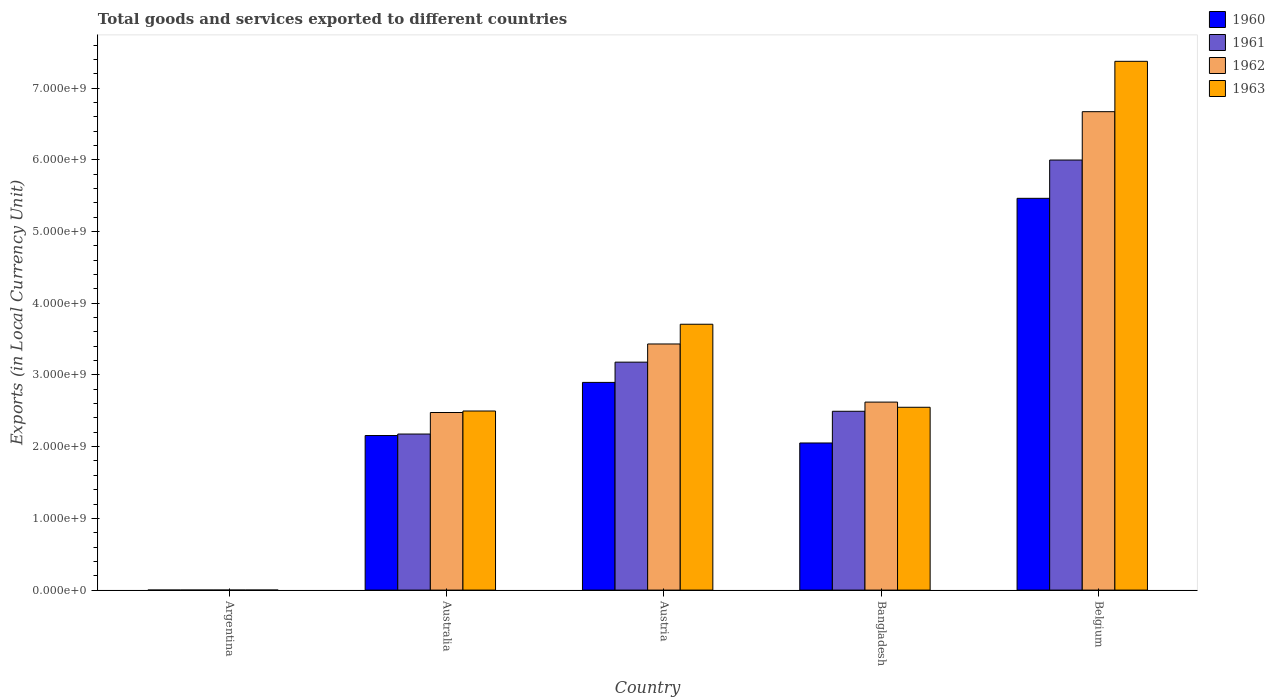How many groups of bars are there?
Provide a short and direct response. 5. Are the number of bars per tick equal to the number of legend labels?
Offer a very short reply. Yes. Are the number of bars on each tick of the X-axis equal?
Your answer should be compact. Yes. How many bars are there on the 2nd tick from the left?
Give a very brief answer. 4. What is the label of the 1st group of bars from the left?
Give a very brief answer. Argentina. What is the Amount of goods and services exports in 1961 in Australia?
Provide a short and direct response. 2.18e+09. Across all countries, what is the maximum Amount of goods and services exports in 1961?
Keep it short and to the point. 6.00e+09. Across all countries, what is the minimum Amount of goods and services exports in 1961?
Your answer should be compact. 0.01. What is the total Amount of goods and services exports in 1962 in the graph?
Ensure brevity in your answer.  1.52e+1. What is the difference between the Amount of goods and services exports in 1961 in Australia and that in Belgium?
Provide a succinct answer. -3.82e+09. What is the difference between the Amount of goods and services exports in 1962 in Argentina and the Amount of goods and services exports in 1961 in Bangladesh?
Keep it short and to the point. -2.49e+09. What is the average Amount of goods and services exports in 1963 per country?
Provide a succinct answer. 3.23e+09. What is the difference between the Amount of goods and services exports of/in 1960 and Amount of goods and services exports of/in 1963 in Argentina?
Provide a succinct answer. -0.01. What is the ratio of the Amount of goods and services exports in 1963 in Australia to that in Bangladesh?
Provide a succinct answer. 0.98. Is the Amount of goods and services exports in 1963 in Argentina less than that in Austria?
Offer a very short reply. Yes. What is the difference between the highest and the second highest Amount of goods and services exports in 1963?
Your answer should be very brief. 3.67e+09. What is the difference between the highest and the lowest Amount of goods and services exports in 1963?
Keep it short and to the point. 7.37e+09. Is the sum of the Amount of goods and services exports in 1963 in Australia and Austria greater than the maximum Amount of goods and services exports in 1960 across all countries?
Keep it short and to the point. Yes. What does the 1st bar from the left in Argentina represents?
Provide a succinct answer. 1960. What does the 3rd bar from the right in Australia represents?
Offer a terse response. 1961. Is it the case that in every country, the sum of the Amount of goods and services exports in 1963 and Amount of goods and services exports in 1961 is greater than the Amount of goods and services exports in 1962?
Keep it short and to the point. Yes. How many bars are there?
Provide a succinct answer. 20. Are all the bars in the graph horizontal?
Give a very brief answer. No. What is the difference between two consecutive major ticks on the Y-axis?
Keep it short and to the point. 1.00e+09. Are the values on the major ticks of Y-axis written in scientific E-notation?
Give a very brief answer. Yes. Does the graph contain any zero values?
Provide a succinct answer. No. How many legend labels are there?
Provide a succinct answer. 4. What is the title of the graph?
Keep it short and to the point. Total goods and services exported to different countries. Does "1970" appear as one of the legend labels in the graph?
Provide a short and direct response. No. What is the label or title of the X-axis?
Make the answer very short. Country. What is the label or title of the Y-axis?
Provide a short and direct response. Exports (in Local Currency Unit). What is the Exports (in Local Currency Unit) in 1960 in Argentina?
Offer a terse response. 0.01. What is the Exports (in Local Currency Unit) of 1961 in Argentina?
Your answer should be compact. 0.01. What is the Exports (in Local Currency Unit) in 1962 in Argentina?
Give a very brief answer. 0.01. What is the Exports (in Local Currency Unit) in 1963 in Argentina?
Your answer should be very brief. 0.02. What is the Exports (in Local Currency Unit) in 1960 in Australia?
Offer a terse response. 2.16e+09. What is the Exports (in Local Currency Unit) in 1961 in Australia?
Keep it short and to the point. 2.18e+09. What is the Exports (in Local Currency Unit) of 1962 in Australia?
Give a very brief answer. 2.48e+09. What is the Exports (in Local Currency Unit) of 1963 in Australia?
Provide a short and direct response. 2.50e+09. What is the Exports (in Local Currency Unit) of 1960 in Austria?
Offer a terse response. 2.90e+09. What is the Exports (in Local Currency Unit) in 1961 in Austria?
Your answer should be very brief. 3.18e+09. What is the Exports (in Local Currency Unit) in 1962 in Austria?
Provide a short and direct response. 3.43e+09. What is the Exports (in Local Currency Unit) of 1963 in Austria?
Offer a very short reply. 3.71e+09. What is the Exports (in Local Currency Unit) of 1960 in Bangladesh?
Keep it short and to the point. 2.05e+09. What is the Exports (in Local Currency Unit) in 1961 in Bangladesh?
Provide a succinct answer. 2.49e+09. What is the Exports (in Local Currency Unit) of 1962 in Bangladesh?
Keep it short and to the point. 2.62e+09. What is the Exports (in Local Currency Unit) of 1963 in Bangladesh?
Your answer should be very brief. 2.55e+09. What is the Exports (in Local Currency Unit) of 1960 in Belgium?
Give a very brief answer. 5.46e+09. What is the Exports (in Local Currency Unit) of 1961 in Belgium?
Give a very brief answer. 6.00e+09. What is the Exports (in Local Currency Unit) of 1962 in Belgium?
Provide a succinct answer. 6.67e+09. What is the Exports (in Local Currency Unit) of 1963 in Belgium?
Your answer should be compact. 7.37e+09. Across all countries, what is the maximum Exports (in Local Currency Unit) of 1960?
Offer a terse response. 5.46e+09. Across all countries, what is the maximum Exports (in Local Currency Unit) in 1961?
Your answer should be compact. 6.00e+09. Across all countries, what is the maximum Exports (in Local Currency Unit) of 1962?
Offer a terse response. 6.67e+09. Across all countries, what is the maximum Exports (in Local Currency Unit) in 1963?
Your response must be concise. 7.37e+09. Across all countries, what is the minimum Exports (in Local Currency Unit) of 1960?
Your answer should be very brief. 0.01. Across all countries, what is the minimum Exports (in Local Currency Unit) in 1961?
Ensure brevity in your answer.  0.01. Across all countries, what is the minimum Exports (in Local Currency Unit) of 1962?
Keep it short and to the point. 0.01. Across all countries, what is the minimum Exports (in Local Currency Unit) of 1963?
Provide a succinct answer. 0.02. What is the total Exports (in Local Currency Unit) of 1960 in the graph?
Your response must be concise. 1.26e+1. What is the total Exports (in Local Currency Unit) in 1961 in the graph?
Offer a terse response. 1.38e+1. What is the total Exports (in Local Currency Unit) in 1962 in the graph?
Give a very brief answer. 1.52e+1. What is the total Exports (in Local Currency Unit) in 1963 in the graph?
Keep it short and to the point. 1.61e+1. What is the difference between the Exports (in Local Currency Unit) in 1960 in Argentina and that in Australia?
Your response must be concise. -2.15e+09. What is the difference between the Exports (in Local Currency Unit) in 1961 in Argentina and that in Australia?
Give a very brief answer. -2.18e+09. What is the difference between the Exports (in Local Currency Unit) in 1962 in Argentina and that in Australia?
Make the answer very short. -2.48e+09. What is the difference between the Exports (in Local Currency Unit) of 1963 in Argentina and that in Australia?
Give a very brief answer. -2.50e+09. What is the difference between the Exports (in Local Currency Unit) in 1960 in Argentina and that in Austria?
Your answer should be very brief. -2.90e+09. What is the difference between the Exports (in Local Currency Unit) in 1961 in Argentina and that in Austria?
Provide a short and direct response. -3.18e+09. What is the difference between the Exports (in Local Currency Unit) in 1962 in Argentina and that in Austria?
Your answer should be very brief. -3.43e+09. What is the difference between the Exports (in Local Currency Unit) in 1963 in Argentina and that in Austria?
Your response must be concise. -3.71e+09. What is the difference between the Exports (in Local Currency Unit) of 1960 in Argentina and that in Bangladesh?
Provide a short and direct response. -2.05e+09. What is the difference between the Exports (in Local Currency Unit) of 1961 in Argentina and that in Bangladesh?
Offer a terse response. -2.49e+09. What is the difference between the Exports (in Local Currency Unit) in 1962 in Argentina and that in Bangladesh?
Provide a succinct answer. -2.62e+09. What is the difference between the Exports (in Local Currency Unit) of 1963 in Argentina and that in Bangladesh?
Keep it short and to the point. -2.55e+09. What is the difference between the Exports (in Local Currency Unit) in 1960 in Argentina and that in Belgium?
Provide a succinct answer. -5.46e+09. What is the difference between the Exports (in Local Currency Unit) of 1961 in Argentina and that in Belgium?
Provide a short and direct response. -6.00e+09. What is the difference between the Exports (in Local Currency Unit) of 1962 in Argentina and that in Belgium?
Provide a succinct answer. -6.67e+09. What is the difference between the Exports (in Local Currency Unit) in 1963 in Argentina and that in Belgium?
Offer a very short reply. -7.37e+09. What is the difference between the Exports (in Local Currency Unit) in 1960 in Australia and that in Austria?
Your response must be concise. -7.41e+08. What is the difference between the Exports (in Local Currency Unit) in 1961 in Australia and that in Austria?
Keep it short and to the point. -1.00e+09. What is the difference between the Exports (in Local Currency Unit) in 1962 in Australia and that in Austria?
Your response must be concise. -9.56e+08. What is the difference between the Exports (in Local Currency Unit) in 1963 in Australia and that in Austria?
Your response must be concise. -1.21e+09. What is the difference between the Exports (in Local Currency Unit) of 1960 in Australia and that in Bangladesh?
Offer a terse response. 1.04e+08. What is the difference between the Exports (in Local Currency Unit) of 1961 in Australia and that in Bangladesh?
Keep it short and to the point. -3.17e+08. What is the difference between the Exports (in Local Currency Unit) in 1962 in Australia and that in Bangladesh?
Offer a very short reply. -1.45e+08. What is the difference between the Exports (in Local Currency Unit) in 1963 in Australia and that in Bangladesh?
Your answer should be very brief. -5.21e+07. What is the difference between the Exports (in Local Currency Unit) of 1960 in Australia and that in Belgium?
Keep it short and to the point. -3.31e+09. What is the difference between the Exports (in Local Currency Unit) in 1961 in Australia and that in Belgium?
Your response must be concise. -3.82e+09. What is the difference between the Exports (in Local Currency Unit) of 1962 in Australia and that in Belgium?
Give a very brief answer. -4.19e+09. What is the difference between the Exports (in Local Currency Unit) of 1963 in Australia and that in Belgium?
Provide a succinct answer. -4.88e+09. What is the difference between the Exports (in Local Currency Unit) in 1960 in Austria and that in Bangladesh?
Your response must be concise. 8.45e+08. What is the difference between the Exports (in Local Currency Unit) in 1961 in Austria and that in Bangladesh?
Keep it short and to the point. 6.85e+08. What is the difference between the Exports (in Local Currency Unit) of 1962 in Austria and that in Bangladesh?
Keep it short and to the point. 8.10e+08. What is the difference between the Exports (in Local Currency Unit) of 1963 in Austria and that in Bangladesh?
Provide a short and direct response. 1.16e+09. What is the difference between the Exports (in Local Currency Unit) in 1960 in Austria and that in Belgium?
Your answer should be very brief. -2.57e+09. What is the difference between the Exports (in Local Currency Unit) of 1961 in Austria and that in Belgium?
Provide a short and direct response. -2.82e+09. What is the difference between the Exports (in Local Currency Unit) in 1962 in Austria and that in Belgium?
Give a very brief answer. -3.24e+09. What is the difference between the Exports (in Local Currency Unit) of 1963 in Austria and that in Belgium?
Offer a very short reply. -3.67e+09. What is the difference between the Exports (in Local Currency Unit) of 1960 in Bangladesh and that in Belgium?
Your answer should be very brief. -3.41e+09. What is the difference between the Exports (in Local Currency Unit) in 1961 in Bangladesh and that in Belgium?
Provide a short and direct response. -3.50e+09. What is the difference between the Exports (in Local Currency Unit) of 1962 in Bangladesh and that in Belgium?
Keep it short and to the point. -4.05e+09. What is the difference between the Exports (in Local Currency Unit) in 1963 in Bangladesh and that in Belgium?
Provide a short and direct response. -4.82e+09. What is the difference between the Exports (in Local Currency Unit) in 1960 in Argentina and the Exports (in Local Currency Unit) in 1961 in Australia?
Provide a short and direct response. -2.18e+09. What is the difference between the Exports (in Local Currency Unit) in 1960 in Argentina and the Exports (in Local Currency Unit) in 1962 in Australia?
Give a very brief answer. -2.48e+09. What is the difference between the Exports (in Local Currency Unit) in 1960 in Argentina and the Exports (in Local Currency Unit) in 1963 in Australia?
Offer a very short reply. -2.50e+09. What is the difference between the Exports (in Local Currency Unit) of 1961 in Argentina and the Exports (in Local Currency Unit) of 1962 in Australia?
Your answer should be compact. -2.48e+09. What is the difference between the Exports (in Local Currency Unit) in 1961 in Argentina and the Exports (in Local Currency Unit) in 1963 in Australia?
Offer a very short reply. -2.50e+09. What is the difference between the Exports (in Local Currency Unit) of 1962 in Argentina and the Exports (in Local Currency Unit) of 1963 in Australia?
Make the answer very short. -2.50e+09. What is the difference between the Exports (in Local Currency Unit) in 1960 in Argentina and the Exports (in Local Currency Unit) in 1961 in Austria?
Ensure brevity in your answer.  -3.18e+09. What is the difference between the Exports (in Local Currency Unit) of 1960 in Argentina and the Exports (in Local Currency Unit) of 1962 in Austria?
Give a very brief answer. -3.43e+09. What is the difference between the Exports (in Local Currency Unit) in 1960 in Argentina and the Exports (in Local Currency Unit) in 1963 in Austria?
Give a very brief answer. -3.71e+09. What is the difference between the Exports (in Local Currency Unit) of 1961 in Argentina and the Exports (in Local Currency Unit) of 1962 in Austria?
Make the answer very short. -3.43e+09. What is the difference between the Exports (in Local Currency Unit) of 1961 in Argentina and the Exports (in Local Currency Unit) of 1963 in Austria?
Your answer should be compact. -3.71e+09. What is the difference between the Exports (in Local Currency Unit) in 1962 in Argentina and the Exports (in Local Currency Unit) in 1963 in Austria?
Your answer should be compact. -3.71e+09. What is the difference between the Exports (in Local Currency Unit) of 1960 in Argentina and the Exports (in Local Currency Unit) of 1961 in Bangladesh?
Make the answer very short. -2.49e+09. What is the difference between the Exports (in Local Currency Unit) of 1960 in Argentina and the Exports (in Local Currency Unit) of 1962 in Bangladesh?
Your answer should be very brief. -2.62e+09. What is the difference between the Exports (in Local Currency Unit) in 1960 in Argentina and the Exports (in Local Currency Unit) in 1963 in Bangladesh?
Your response must be concise. -2.55e+09. What is the difference between the Exports (in Local Currency Unit) of 1961 in Argentina and the Exports (in Local Currency Unit) of 1962 in Bangladesh?
Keep it short and to the point. -2.62e+09. What is the difference between the Exports (in Local Currency Unit) in 1961 in Argentina and the Exports (in Local Currency Unit) in 1963 in Bangladesh?
Provide a short and direct response. -2.55e+09. What is the difference between the Exports (in Local Currency Unit) in 1962 in Argentina and the Exports (in Local Currency Unit) in 1963 in Bangladesh?
Provide a short and direct response. -2.55e+09. What is the difference between the Exports (in Local Currency Unit) in 1960 in Argentina and the Exports (in Local Currency Unit) in 1961 in Belgium?
Offer a very short reply. -6.00e+09. What is the difference between the Exports (in Local Currency Unit) in 1960 in Argentina and the Exports (in Local Currency Unit) in 1962 in Belgium?
Your response must be concise. -6.67e+09. What is the difference between the Exports (in Local Currency Unit) of 1960 in Argentina and the Exports (in Local Currency Unit) of 1963 in Belgium?
Make the answer very short. -7.37e+09. What is the difference between the Exports (in Local Currency Unit) of 1961 in Argentina and the Exports (in Local Currency Unit) of 1962 in Belgium?
Provide a succinct answer. -6.67e+09. What is the difference between the Exports (in Local Currency Unit) in 1961 in Argentina and the Exports (in Local Currency Unit) in 1963 in Belgium?
Make the answer very short. -7.37e+09. What is the difference between the Exports (in Local Currency Unit) in 1962 in Argentina and the Exports (in Local Currency Unit) in 1963 in Belgium?
Your answer should be very brief. -7.37e+09. What is the difference between the Exports (in Local Currency Unit) in 1960 in Australia and the Exports (in Local Currency Unit) in 1961 in Austria?
Provide a succinct answer. -1.02e+09. What is the difference between the Exports (in Local Currency Unit) of 1960 in Australia and the Exports (in Local Currency Unit) of 1962 in Austria?
Your answer should be compact. -1.28e+09. What is the difference between the Exports (in Local Currency Unit) of 1960 in Australia and the Exports (in Local Currency Unit) of 1963 in Austria?
Offer a terse response. -1.55e+09. What is the difference between the Exports (in Local Currency Unit) of 1961 in Australia and the Exports (in Local Currency Unit) of 1962 in Austria?
Provide a short and direct response. -1.26e+09. What is the difference between the Exports (in Local Currency Unit) of 1961 in Australia and the Exports (in Local Currency Unit) of 1963 in Austria?
Your response must be concise. -1.53e+09. What is the difference between the Exports (in Local Currency Unit) of 1962 in Australia and the Exports (in Local Currency Unit) of 1963 in Austria?
Your answer should be compact. -1.23e+09. What is the difference between the Exports (in Local Currency Unit) in 1960 in Australia and the Exports (in Local Currency Unit) in 1961 in Bangladesh?
Give a very brief answer. -3.38e+08. What is the difference between the Exports (in Local Currency Unit) in 1960 in Australia and the Exports (in Local Currency Unit) in 1962 in Bangladesh?
Provide a succinct answer. -4.66e+08. What is the difference between the Exports (in Local Currency Unit) of 1960 in Australia and the Exports (in Local Currency Unit) of 1963 in Bangladesh?
Your answer should be compact. -3.94e+08. What is the difference between the Exports (in Local Currency Unit) of 1961 in Australia and the Exports (in Local Currency Unit) of 1962 in Bangladesh?
Your response must be concise. -4.45e+08. What is the difference between the Exports (in Local Currency Unit) in 1961 in Australia and the Exports (in Local Currency Unit) in 1963 in Bangladesh?
Make the answer very short. -3.73e+08. What is the difference between the Exports (in Local Currency Unit) in 1962 in Australia and the Exports (in Local Currency Unit) in 1963 in Bangladesh?
Provide a short and direct response. -7.31e+07. What is the difference between the Exports (in Local Currency Unit) in 1960 in Australia and the Exports (in Local Currency Unit) in 1961 in Belgium?
Your response must be concise. -3.84e+09. What is the difference between the Exports (in Local Currency Unit) in 1960 in Australia and the Exports (in Local Currency Unit) in 1962 in Belgium?
Provide a succinct answer. -4.52e+09. What is the difference between the Exports (in Local Currency Unit) of 1960 in Australia and the Exports (in Local Currency Unit) of 1963 in Belgium?
Your response must be concise. -5.22e+09. What is the difference between the Exports (in Local Currency Unit) in 1961 in Australia and the Exports (in Local Currency Unit) in 1962 in Belgium?
Give a very brief answer. -4.49e+09. What is the difference between the Exports (in Local Currency Unit) in 1961 in Australia and the Exports (in Local Currency Unit) in 1963 in Belgium?
Give a very brief answer. -5.20e+09. What is the difference between the Exports (in Local Currency Unit) of 1962 in Australia and the Exports (in Local Currency Unit) of 1963 in Belgium?
Provide a succinct answer. -4.90e+09. What is the difference between the Exports (in Local Currency Unit) of 1960 in Austria and the Exports (in Local Currency Unit) of 1961 in Bangladesh?
Provide a short and direct response. 4.03e+08. What is the difference between the Exports (in Local Currency Unit) in 1960 in Austria and the Exports (in Local Currency Unit) in 1962 in Bangladesh?
Give a very brief answer. 2.75e+08. What is the difference between the Exports (in Local Currency Unit) in 1960 in Austria and the Exports (in Local Currency Unit) in 1963 in Bangladesh?
Provide a short and direct response. 3.47e+08. What is the difference between the Exports (in Local Currency Unit) of 1961 in Austria and the Exports (in Local Currency Unit) of 1962 in Bangladesh?
Provide a short and direct response. 5.57e+08. What is the difference between the Exports (in Local Currency Unit) in 1961 in Austria and the Exports (in Local Currency Unit) in 1963 in Bangladesh?
Keep it short and to the point. 6.29e+08. What is the difference between the Exports (in Local Currency Unit) in 1962 in Austria and the Exports (in Local Currency Unit) in 1963 in Bangladesh?
Offer a terse response. 8.83e+08. What is the difference between the Exports (in Local Currency Unit) in 1960 in Austria and the Exports (in Local Currency Unit) in 1961 in Belgium?
Give a very brief answer. -3.10e+09. What is the difference between the Exports (in Local Currency Unit) in 1960 in Austria and the Exports (in Local Currency Unit) in 1962 in Belgium?
Give a very brief answer. -3.77e+09. What is the difference between the Exports (in Local Currency Unit) of 1960 in Austria and the Exports (in Local Currency Unit) of 1963 in Belgium?
Keep it short and to the point. -4.48e+09. What is the difference between the Exports (in Local Currency Unit) in 1961 in Austria and the Exports (in Local Currency Unit) in 1962 in Belgium?
Make the answer very short. -3.49e+09. What is the difference between the Exports (in Local Currency Unit) of 1961 in Austria and the Exports (in Local Currency Unit) of 1963 in Belgium?
Keep it short and to the point. -4.19e+09. What is the difference between the Exports (in Local Currency Unit) in 1962 in Austria and the Exports (in Local Currency Unit) in 1963 in Belgium?
Your answer should be compact. -3.94e+09. What is the difference between the Exports (in Local Currency Unit) in 1960 in Bangladesh and the Exports (in Local Currency Unit) in 1961 in Belgium?
Offer a terse response. -3.94e+09. What is the difference between the Exports (in Local Currency Unit) of 1960 in Bangladesh and the Exports (in Local Currency Unit) of 1962 in Belgium?
Provide a succinct answer. -4.62e+09. What is the difference between the Exports (in Local Currency Unit) in 1960 in Bangladesh and the Exports (in Local Currency Unit) in 1963 in Belgium?
Ensure brevity in your answer.  -5.32e+09. What is the difference between the Exports (in Local Currency Unit) in 1961 in Bangladesh and the Exports (in Local Currency Unit) in 1962 in Belgium?
Provide a short and direct response. -4.18e+09. What is the difference between the Exports (in Local Currency Unit) of 1961 in Bangladesh and the Exports (in Local Currency Unit) of 1963 in Belgium?
Offer a very short reply. -4.88e+09. What is the difference between the Exports (in Local Currency Unit) in 1962 in Bangladesh and the Exports (in Local Currency Unit) in 1963 in Belgium?
Make the answer very short. -4.75e+09. What is the average Exports (in Local Currency Unit) in 1960 per country?
Your answer should be very brief. 2.51e+09. What is the average Exports (in Local Currency Unit) of 1961 per country?
Provide a succinct answer. 2.77e+09. What is the average Exports (in Local Currency Unit) in 1962 per country?
Your answer should be compact. 3.04e+09. What is the average Exports (in Local Currency Unit) of 1963 per country?
Give a very brief answer. 3.23e+09. What is the difference between the Exports (in Local Currency Unit) of 1960 and Exports (in Local Currency Unit) of 1961 in Argentina?
Provide a short and direct response. 0. What is the difference between the Exports (in Local Currency Unit) of 1960 and Exports (in Local Currency Unit) of 1962 in Argentina?
Provide a succinct answer. 0. What is the difference between the Exports (in Local Currency Unit) of 1960 and Exports (in Local Currency Unit) of 1963 in Argentina?
Provide a succinct answer. -0.01. What is the difference between the Exports (in Local Currency Unit) in 1961 and Exports (in Local Currency Unit) in 1963 in Argentina?
Offer a very short reply. -0.01. What is the difference between the Exports (in Local Currency Unit) in 1962 and Exports (in Local Currency Unit) in 1963 in Argentina?
Your answer should be compact. -0.01. What is the difference between the Exports (in Local Currency Unit) of 1960 and Exports (in Local Currency Unit) of 1961 in Australia?
Ensure brevity in your answer.  -2.10e+07. What is the difference between the Exports (in Local Currency Unit) in 1960 and Exports (in Local Currency Unit) in 1962 in Australia?
Provide a short and direct response. -3.21e+08. What is the difference between the Exports (in Local Currency Unit) of 1960 and Exports (in Local Currency Unit) of 1963 in Australia?
Give a very brief answer. -3.42e+08. What is the difference between the Exports (in Local Currency Unit) of 1961 and Exports (in Local Currency Unit) of 1962 in Australia?
Make the answer very short. -3.00e+08. What is the difference between the Exports (in Local Currency Unit) in 1961 and Exports (in Local Currency Unit) in 1963 in Australia?
Provide a succinct answer. -3.21e+08. What is the difference between the Exports (in Local Currency Unit) of 1962 and Exports (in Local Currency Unit) of 1963 in Australia?
Provide a succinct answer. -2.10e+07. What is the difference between the Exports (in Local Currency Unit) in 1960 and Exports (in Local Currency Unit) in 1961 in Austria?
Your response must be concise. -2.82e+08. What is the difference between the Exports (in Local Currency Unit) of 1960 and Exports (in Local Currency Unit) of 1962 in Austria?
Ensure brevity in your answer.  -5.36e+08. What is the difference between the Exports (in Local Currency Unit) of 1960 and Exports (in Local Currency Unit) of 1963 in Austria?
Make the answer very short. -8.11e+08. What is the difference between the Exports (in Local Currency Unit) of 1961 and Exports (in Local Currency Unit) of 1962 in Austria?
Your answer should be compact. -2.53e+08. What is the difference between the Exports (in Local Currency Unit) in 1961 and Exports (in Local Currency Unit) in 1963 in Austria?
Offer a terse response. -5.29e+08. What is the difference between the Exports (in Local Currency Unit) of 1962 and Exports (in Local Currency Unit) of 1963 in Austria?
Provide a succinct answer. -2.75e+08. What is the difference between the Exports (in Local Currency Unit) in 1960 and Exports (in Local Currency Unit) in 1961 in Bangladesh?
Your answer should be compact. -4.42e+08. What is the difference between the Exports (in Local Currency Unit) of 1960 and Exports (in Local Currency Unit) of 1962 in Bangladesh?
Offer a terse response. -5.70e+08. What is the difference between the Exports (in Local Currency Unit) in 1960 and Exports (in Local Currency Unit) in 1963 in Bangladesh?
Keep it short and to the point. -4.98e+08. What is the difference between the Exports (in Local Currency Unit) of 1961 and Exports (in Local Currency Unit) of 1962 in Bangladesh?
Ensure brevity in your answer.  -1.28e+08. What is the difference between the Exports (in Local Currency Unit) of 1961 and Exports (in Local Currency Unit) of 1963 in Bangladesh?
Keep it short and to the point. -5.58e+07. What is the difference between the Exports (in Local Currency Unit) in 1962 and Exports (in Local Currency Unit) in 1963 in Bangladesh?
Your answer should be very brief. 7.21e+07. What is the difference between the Exports (in Local Currency Unit) of 1960 and Exports (in Local Currency Unit) of 1961 in Belgium?
Ensure brevity in your answer.  -5.34e+08. What is the difference between the Exports (in Local Currency Unit) of 1960 and Exports (in Local Currency Unit) of 1962 in Belgium?
Provide a short and direct response. -1.21e+09. What is the difference between the Exports (in Local Currency Unit) of 1960 and Exports (in Local Currency Unit) of 1963 in Belgium?
Your answer should be very brief. -1.91e+09. What is the difference between the Exports (in Local Currency Unit) of 1961 and Exports (in Local Currency Unit) of 1962 in Belgium?
Provide a succinct answer. -6.74e+08. What is the difference between the Exports (in Local Currency Unit) of 1961 and Exports (in Local Currency Unit) of 1963 in Belgium?
Your response must be concise. -1.38e+09. What is the difference between the Exports (in Local Currency Unit) of 1962 and Exports (in Local Currency Unit) of 1963 in Belgium?
Ensure brevity in your answer.  -7.02e+08. What is the ratio of the Exports (in Local Currency Unit) of 1961 in Argentina to that in Australia?
Your response must be concise. 0. What is the ratio of the Exports (in Local Currency Unit) in 1962 in Argentina to that in Australia?
Provide a short and direct response. 0. What is the ratio of the Exports (in Local Currency Unit) of 1963 in Argentina to that in Australia?
Give a very brief answer. 0. What is the ratio of the Exports (in Local Currency Unit) in 1961 in Argentina to that in Austria?
Your answer should be compact. 0. What is the ratio of the Exports (in Local Currency Unit) in 1962 in Argentina to that in Austria?
Provide a short and direct response. 0. What is the ratio of the Exports (in Local Currency Unit) in 1960 in Argentina to that in Bangladesh?
Give a very brief answer. 0. What is the ratio of the Exports (in Local Currency Unit) of 1962 in Argentina to that in Bangladesh?
Keep it short and to the point. 0. What is the ratio of the Exports (in Local Currency Unit) of 1963 in Argentina to that in Belgium?
Make the answer very short. 0. What is the ratio of the Exports (in Local Currency Unit) in 1960 in Australia to that in Austria?
Offer a terse response. 0.74. What is the ratio of the Exports (in Local Currency Unit) of 1961 in Australia to that in Austria?
Your answer should be very brief. 0.68. What is the ratio of the Exports (in Local Currency Unit) of 1962 in Australia to that in Austria?
Keep it short and to the point. 0.72. What is the ratio of the Exports (in Local Currency Unit) in 1963 in Australia to that in Austria?
Offer a very short reply. 0.67. What is the ratio of the Exports (in Local Currency Unit) of 1960 in Australia to that in Bangladesh?
Ensure brevity in your answer.  1.05. What is the ratio of the Exports (in Local Currency Unit) in 1961 in Australia to that in Bangladesh?
Give a very brief answer. 0.87. What is the ratio of the Exports (in Local Currency Unit) of 1962 in Australia to that in Bangladesh?
Offer a terse response. 0.94. What is the ratio of the Exports (in Local Currency Unit) of 1963 in Australia to that in Bangladesh?
Your response must be concise. 0.98. What is the ratio of the Exports (in Local Currency Unit) of 1960 in Australia to that in Belgium?
Give a very brief answer. 0.39. What is the ratio of the Exports (in Local Currency Unit) in 1961 in Australia to that in Belgium?
Offer a very short reply. 0.36. What is the ratio of the Exports (in Local Currency Unit) of 1962 in Australia to that in Belgium?
Your response must be concise. 0.37. What is the ratio of the Exports (in Local Currency Unit) in 1963 in Australia to that in Belgium?
Keep it short and to the point. 0.34. What is the ratio of the Exports (in Local Currency Unit) in 1960 in Austria to that in Bangladesh?
Your answer should be compact. 1.41. What is the ratio of the Exports (in Local Currency Unit) in 1961 in Austria to that in Bangladesh?
Your answer should be very brief. 1.27. What is the ratio of the Exports (in Local Currency Unit) in 1962 in Austria to that in Bangladesh?
Provide a short and direct response. 1.31. What is the ratio of the Exports (in Local Currency Unit) of 1963 in Austria to that in Bangladesh?
Make the answer very short. 1.45. What is the ratio of the Exports (in Local Currency Unit) in 1960 in Austria to that in Belgium?
Give a very brief answer. 0.53. What is the ratio of the Exports (in Local Currency Unit) of 1961 in Austria to that in Belgium?
Provide a succinct answer. 0.53. What is the ratio of the Exports (in Local Currency Unit) in 1962 in Austria to that in Belgium?
Your response must be concise. 0.51. What is the ratio of the Exports (in Local Currency Unit) of 1963 in Austria to that in Belgium?
Give a very brief answer. 0.5. What is the ratio of the Exports (in Local Currency Unit) of 1960 in Bangladesh to that in Belgium?
Your response must be concise. 0.38. What is the ratio of the Exports (in Local Currency Unit) of 1961 in Bangladesh to that in Belgium?
Keep it short and to the point. 0.42. What is the ratio of the Exports (in Local Currency Unit) of 1962 in Bangladesh to that in Belgium?
Ensure brevity in your answer.  0.39. What is the ratio of the Exports (in Local Currency Unit) in 1963 in Bangladesh to that in Belgium?
Make the answer very short. 0.35. What is the difference between the highest and the second highest Exports (in Local Currency Unit) in 1960?
Provide a succinct answer. 2.57e+09. What is the difference between the highest and the second highest Exports (in Local Currency Unit) in 1961?
Offer a terse response. 2.82e+09. What is the difference between the highest and the second highest Exports (in Local Currency Unit) in 1962?
Ensure brevity in your answer.  3.24e+09. What is the difference between the highest and the second highest Exports (in Local Currency Unit) of 1963?
Offer a very short reply. 3.67e+09. What is the difference between the highest and the lowest Exports (in Local Currency Unit) of 1960?
Your answer should be very brief. 5.46e+09. What is the difference between the highest and the lowest Exports (in Local Currency Unit) in 1961?
Provide a succinct answer. 6.00e+09. What is the difference between the highest and the lowest Exports (in Local Currency Unit) of 1962?
Your response must be concise. 6.67e+09. What is the difference between the highest and the lowest Exports (in Local Currency Unit) of 1963?
Make the answer very short. 7.37e+09. 